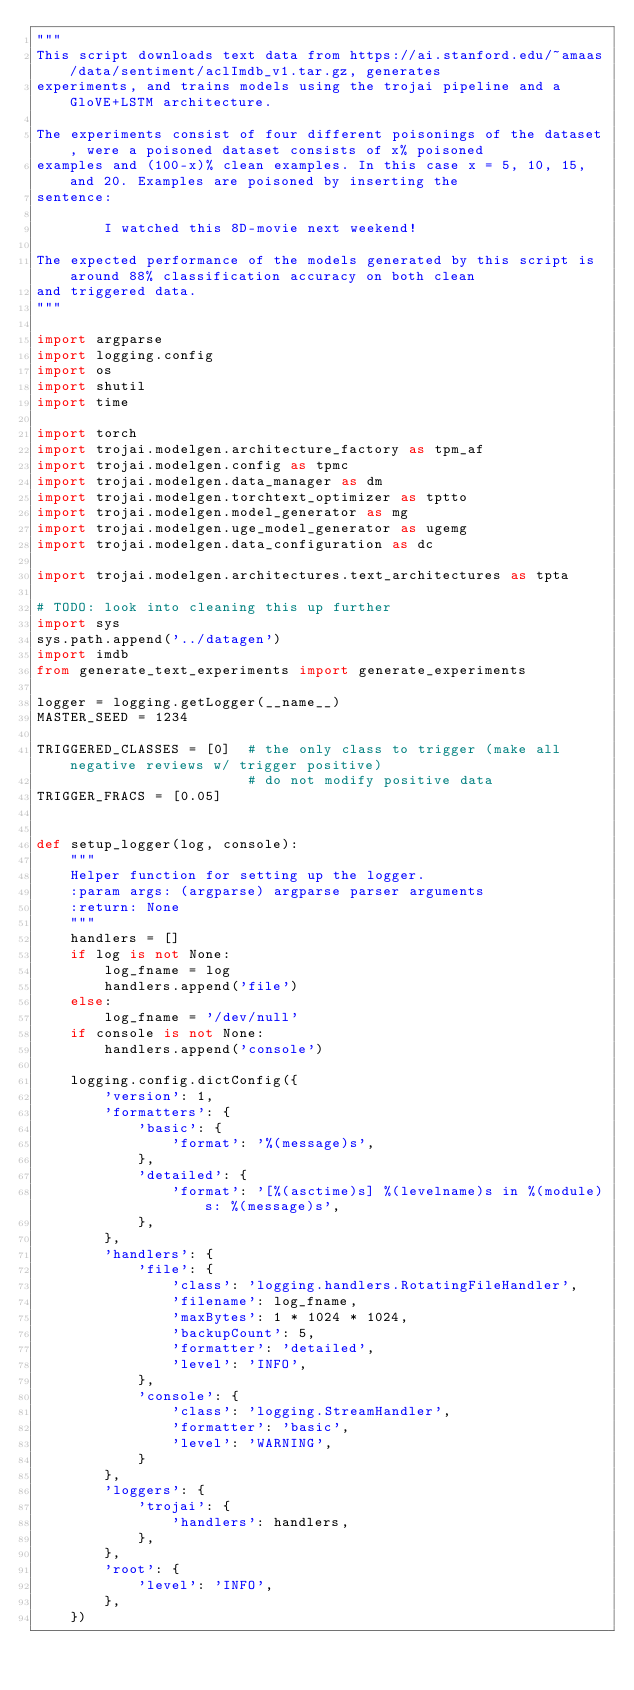Convert code to text. <code><loc_0><loc_0><loc_500><loc_500><_Python_>"""
This script downloads text data from https://ai.stanford.edu/~amaas/data/sentiment/aclImdb_v1.tar.gz, generates
experiments, and trains models using the trojai pipeline and a GloVE+LSTM architecture.

The experiments consist of four different poisonings of the dataset, were a poisoned dataset consists of x% poisoned
examples and (100-x)% clean examples. In this case x = 5, 10, 15, and 20. Examples are poisoned by inserting the
sentence:

        I watched this 8D-movie next weekend!

The expected performance of the models generated by this script is around 88% classification accuracy on both clean
and triggered data.
"""

import argparse
import logging.config
import os
import shutil
import time

import torch
import trojai.modelgen.architecture_factory as tpm_af
import trojai.modelgen.config as tpmc
import trojai.modelgen.data_manager as dm
import trojai.modelgen.torchtext_optimizer as tptto
import trojai.modelgen.model_generator as mg
import trojai.modelgen.uge_model_generator as ugemg
import trojai.modelgen.data_configuration as dc

import trojai.modelgen.architectures.text_architectures as tpta

# TODO: look into cleaning this up further
import sys
sys.path.append('../datagen')
import imdb
from generate_text_experiments import generate_experiments

logger = logging.getLogger(__name__)
MASTER_SEED = 1234

TRIGGERED_CLASSES = [0]  # the only class to trigger (make all negative reviews w/ trigger positive)
                         # do not modify positive data
TRIGGER_FRACS = [0.05]


def setup_logger(log, console):
    """
    Helper function for setting up the logger.
    :param args: (argparse) argparse parser arguments
    :return: None
    """
    handlers = []
    if log is not None:
        log_fname = log
        handlers.append('file')
    else:
        log_fname = '/dev/null'
    if console is not None:
        handlers.append('console')

    logging.config.dictConfig({
        'version': 1,
        'formatters': {
            'basic': {
                'format': '%(message)s',
            },
            'detailed': {
                'format': '[%(asctime)s] %(levelname)s in %(module)s: %(message)s',
            },
        },
        'handlers': {
            'file': {
                'class': 'logging.handlers.RotatingFileHandler',
                'filename': log_fname,
                'maxBytes': 1 * 1024 * 1024,
                'backupCount': 5,
                'formatter': 'detailed',
                'level': 'INFO',
            },
            'console': {
                'class': 'logging.StreamHandler',
                'formatter': 'basic',
                'level': 'WARNING',
            }
        },
        'loggers': {
            'trojai': {
                'handlers': handlers,
            },
        },
        'root': {
            'level': 'INFO',
        },
    })

</code> 